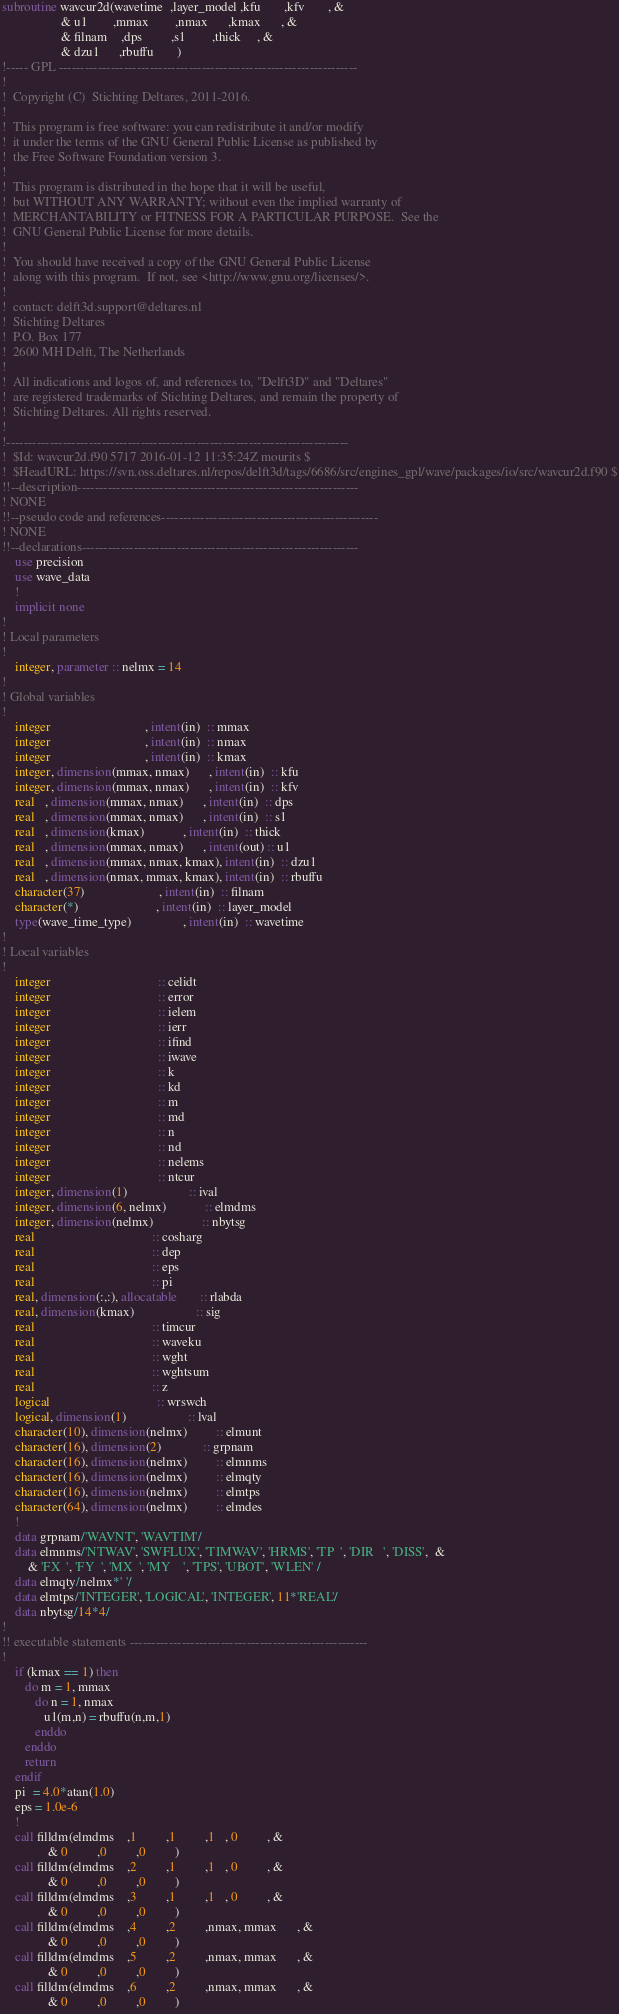<code> <loc_0><loc_0><loc_500><loc_500><_FORTRAN_>subroutine wavcur2d(wavetime  ,layer_model ,kfu       ,kfv       , &
                  & u1        ,mmax        ,nmax      ,kmax      , &
                  & filnam    ,dps         ,s1        ,thick     , &
                  & dzu1      ,rbuffu       )
!----- GPL ---------------------------------------------------------------------
!                                                                               
!  Copyright (C)  Stichting Deltares, 2011-2016.                                
!                                                                               
!  This program is free software: you can redistribute it and/or modify         
!  it under the terms of the GNU General Public License as published by         
!  the Free Software Foundation version 3.                                      
!                                                                               
!  This program is distributed in the hope that it will be useful,              
!  but WITHOUT ANY WARRANTY; without even the implied warranty of               
!  MERCHANTABILITY or FITNESS FOR A PARTICULAR PURPOSE.  See the                
!  GNU General Public License for more details.                                 
!                                                                               
!  You should have received a copy of the GNU General Public License            
!  along with this program.  If not, see <http://www.gnu.org/licenses/>.        
!                                                                               
!  contact: delft3d.support@deltares.nl                                         
!  Stichting Deltares                                                           
!  P.O. Box 177                                                                 
!  2600 MH Delft, The Netherlands                                               
!                                                                               
!  All indications and logos of, and references to, "Delft3D" and "Deltares"    
!  are registered trademarks of Stichting Deltares, and remain the property of  
!  Stichting Deltares. All rights reserved.                                     
!                                                                               
!-------------------------------------------------------------------------------
!  $Id: wavcur2d.f90 5717 2016-01-12 11:35:24Z mourits $
!  $HeadURL: https://svn.oss.deltares.nl/repos/delft3d/tags/6686/src/engines_gpl/wave/packages/io/src/wavcur2d.f90 $
!!--description-----------------------------------------------------------------
! NONE
!!--pseudo code and references--------------------------------------------------
! NONE
!!--declarations----------------------------------------------------------------
    use precision
    use wave_data
    !
    implicit none
!
! Local parameters
!
    integer, parameter :: nelmx = 14 
!
! Global variables
!
    integer                             , intent(in)  :: mmax
    integer                             , intent(in)  :: nmax
    integer                             , intent(in)  :: kmax
    integer, dimension(mmax, nmax)      , intent(in)  :: kfu
    integer, dimension(mmax, nmax)      , intent(in)  :: kfv
    real   , dimension(mmax, nmax)      , intent(in)  :: dps
    real   , dimension(mmax, nmax)      , intent(in)  :: s1
    real   , dimension(kmax)            , intent(in)  :: thick
    real   , dimension(mmax, nmax)      , intent(out) :: u1
    real   , dimension(mmax, nmax, kmax), intent(in)  :: dzu1
    real   , dimension(nmax, mmax, kmax), intent(in)  :: rbuffu
    character(37)                       , intent(in)  :: filnam
    character(*)                        , intent(in)  :: layer_model
    type(wave_time_type)                , intent(in)  :: wavetime
!
! Local variables
!
    integer                                 :: celidt
    integer                                 :: error
    integer                                 :: ielem
    integer                                 :: ierr
    integer                                 :: ifind
    integer                                 :: iwave
    integer                                 :: k
    integer                                 :: kd
    integer                                 :: m
    integer                                 :: md
    integer                                 :: n
    integer                                 :: nd
    integer                                 :: nelems
    integer                                 :: ntcur
    integer, dimension(1)                   :: ival
    integer, dimension(6, nelmx)            :: elmdms
    integer, dimension(nelmx)               :: nbytsg
    real                                    :: cosharg
    real                                    :: dep
    real                                    :: eps
    real                                    :: pi
    real, dimension(:,:), allocatable       :: rlabda
    real, dimension(kmax)                   :: sig
    real                                    :: timcur
    real                                    :: waveku
    real                                    :: wght
    real                                    :: wghtsum
    real                                    :: z
    logical                                 :: wrswch
    logical, dimension(1)                   :: lval
    character(10), dimension(nelmx)         :: elmunt
    character(16), dimension(2)             :: grpnam
    character(16), dimension(nelmx)         :: elmnms
    character(16), dimension(nelmx)         :: elmqty
    character(16), dimension(nelmx)         :: elmtps
    character(64), dimension(nelmx)         :: elmdes
    !
    data grpnam/'WAVNT', 'WAVTIM'/
    data elmnms/'NTWAV', 'SWFLUX', 'TIMWAV', 'HRMS', 'TP  ', 'DIR   ', 'DISS',  &
        & 'FX  ', 'FY  ', 'MX  ', 'MY    ', 'TPS', 'UBOT', 'WLEN' /
    data elmqty/nelmx*' '/
    data elmtps/'INTEGER', 'LOGICAL', 'INTEGER', 11*'REAL'/
    data nbytsg/14*4/ 
!
!! executable statements -------------------------------------------------------
!
    if (kmax == 1) then
       do m = 1, mmax
          do n = 1, nmax
             u1(m,n) = rbuffu(n,m,1)
          enddo
       enddo
       return
    endif
    pi  = 4.0*atan(1.0)
    eps = 1.0e-6
    !
    call filldm(elmdms    ,1         ,1         ,1   , 0         , &
              & 0         ,0         ,0         )
    call filldm(elmdms    ,2         ,1         ,1   , 0         , &
              & 0         ,0         ,0         )
    call filldm(elmdms    ,3         ,1         ,1   , 0         , &
              & 0         ,0         ,0         )
    call filldm(elmdms    ,4         ,2         ,nmax, mmax      , &
              & 0         ,0         ,0         )
    call filldm(elmdms    ,5         ,2         ,nmax, mmax      , &
              & 0         ,0         ,0         )
    call filldm(elmdms    ,6         ,2         ,nmax, mmax      , &
              & 0         ,0         ,0         )</code> 